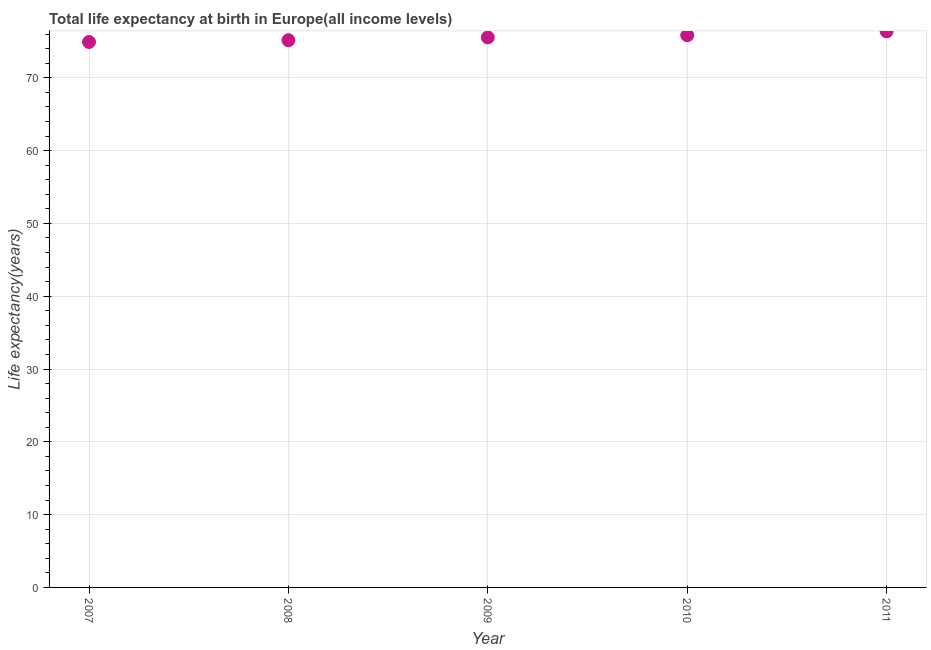What is the life expectancy at birth in 2010?
Provide a short and direct response. 75.85. Across all years, what is the maximum life expectancy at birth?
Make the answer very short. 76.38. Across all years, what is the minimum life expectancy at birth?
Offer a very short reply. 74.92. In which year was the life expectancy at birth maximum?
Your answer should be compact. 2011. What is the sum of the life expectancy at birth?
Offer a terse response. 377.87. What is the difference between the life expectancy at birth in 2009 and 2010?
Offer a very short reply. -0.29. What is the average life expectancy at birth per year?
Your response must be concise. 75.57. What is the median life expectancy at birth?
Give a very brief answer. 75.55. Do a majority of the years between 2009 and 2007 (inclusive) have life expectancy at birth greater than 56 years?
Provide a succinct answer. No. What is the ratio of the life expectancy at birth in 2007 to that in 2010?
Offer a terse response. 0.99. What is the difference between the highest and the second highest life expectancy at birth?
Keep it short and to the point. 0.54. What is the difference between the highest and the lowest life expectancy at birth?
Your answer should be compact. 1.46. How many years are there in the graph?
Your answer should be very brief. 5. What is the difference between two consecutive major ticks on the Y-axis?
Offer a terse response. 10. Are the values on the major ticks of Y-axis written in scientific E-notation?
Offer a very short reply. No. Does the graph contain grids?
Ensure brevity in your answer.  Yes. What is the title of the graph?
Ensure brevity in your answer.  Total life expectancy at birth in Europe(all income levels). What is the label or title of the Y-axis?
Provide a short and direct response. Life expectancy(years). What is the Life expectancy(years) in 2007?
Your answer should be very brief. 74.92. What is the Life expectancy(years) in 2008?
Your response must be concise. 75.17. What is the Life expectancy(years) in 2009?
Provide a short and direct response. 75.55. What is the Life expectancy(years) in 2010?
Your response must be concise. 75.85. What is the Life expectancy(years) in 2011?
Make the answer very short. 76.38. What is the difference between the Life expectancy(years) in 2007 and 2008?
Ensure brevity in your answer.  -0.25. What is the difference between the Life expectancy(years) in 2007 and 2009?
Offer a very short reply. -0.63. What is the difference between the Life expectancy(years) in 2007 and 2010?
Keep it short and to the point. -0.93. What is the difference between the Life expectancy(years) in 2007 and 2011?
Your answer should be compact. -1.46. What is the difference between the Life expectancy(years) in 2008 and 2009?
Your answer should be very brief. -0.39. What is the difference between the Life expectancy(years) in 2008 and 2010?
Your answer should be compact. -0.68. What is the difference between the Life expectancy(years) in 2008 and 2011?
Make the answer very short. -1.22. What is the difference between the Life expectancy(years) in 2009 and 2010?
Your response must be concise. -0.29. What is the difference between the Life expectancy(years) in 2009 and 2011?
Keep it short and to the point. -0.83. What is the difference between the Life expectancy(years) in 2010 and 2011?
Offer a very short reply. -0.54. What is the ratio of the Life expectancy(years) in 2007 to that in 2009?
Ensure brevity in your answer.  0.99. What is the ratio of the Life expectancy(years) in 2007 to that in 2010?
Offer a terse response. 0.99. What is the ratio of the Life expectancy(years) in 2007 to that in 2011?
Offer a terse response. 0.98. What is the ratio of the Life expectancy(years) in 2008 to that in 2009?
Provide a short and direct response. 0.99. What is the ratio of the Life expectancy(years) in 2008 to that in 2010?
Make the answer very short. 0.99. What is the ratio of the Life expectancy(years) in 2009 to that in 2010?
Provide a short and direct response. 1. What is the ratio of the Life expectancy(years) in 2010 to that in 2011?
Your answer should be very brief. 0.99. 